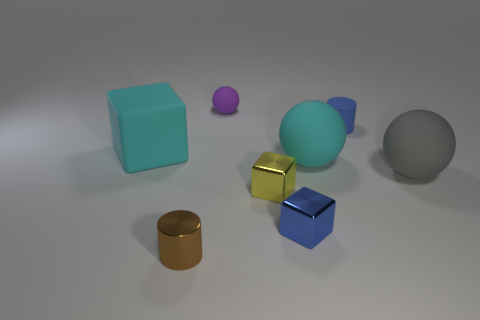Subtract all tiny purple matte spheres. How many spheres are left? 2 Subtract all cubes. How many objects are left? 5 Subtract all cyan balls. How many balls are left? 2 Add 2 blue metallic cubes. How many objects exist? 10 Subtract 0 green balls. How many objects are left? 8 Subtract 1 cylinders. How many cylinders are left? 1 Subtract all brown balls. Subtract all purple cylinders. How many balls are left? 3 Subtract all blue cylinders. How many red cubes are left? 0 Subtract all brown blocks. Subtract all tiny matte objects. How many objects are left? 6 Add 2 matte cylinders. How many matte cylinders are left? 3 